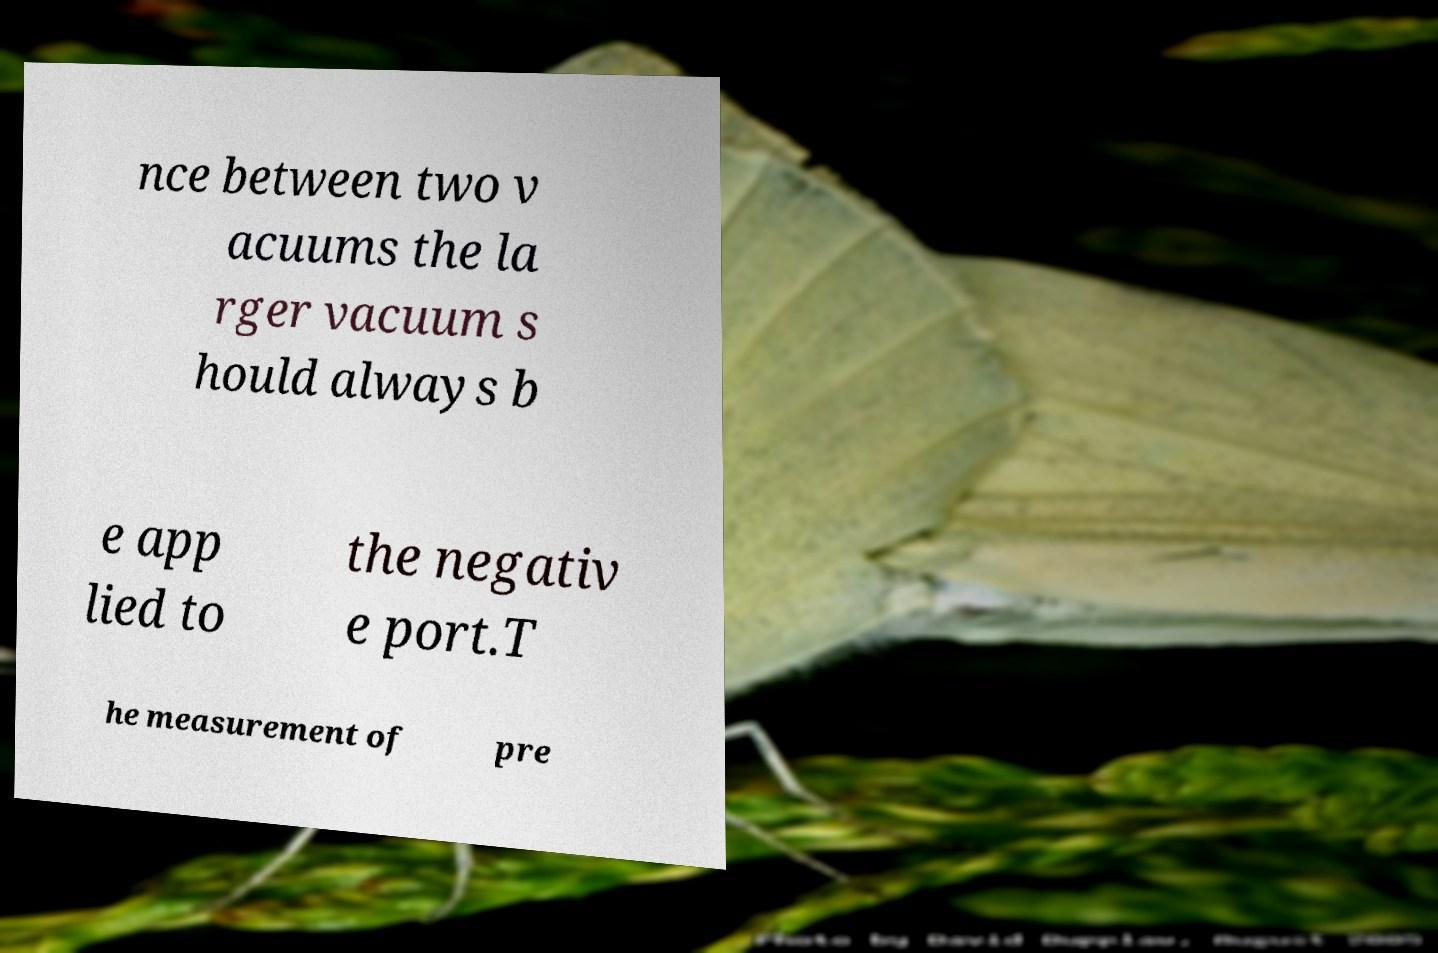Please read and relay the text visible in this image. What does it say? nce between two v acuums the la rger vacuum s hould always b e app lied to the negativ e port.T he measurement of pre 